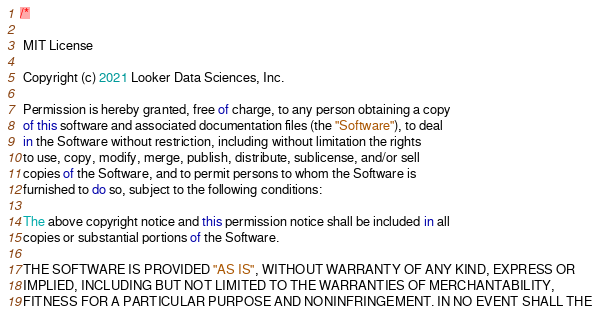<code> <loc_0><loc_0><loc_500><loc_500><_TypeScript_>/*

 MIT License

 Copyright (c) 2021 Looker Data Sciences, Inc.

 Permission is hereby granted, free of charge, to any person obtaining a copy
 of this software and associated documentation files (the "Software"), to deal
 in the Software without restriction, including without limitation the rights
 to use, copy, modify, merge, publish, distribute, sublicense, and/or sell
 copies of the Software, and to permit persons to whom the Software is
 furnished to do so, subject to the following conditions:

 The above copyright notice and this permission notice shall be included in all
 copies or substantial portions of the Software.

 THE SOFTWARE IS PROVIDED "AS IS", WITHOUT WARRANTY OF ANY KIND, EXPRESS OR
 IMPLIED, INCLUDING BUT NOT LIMITED TO THE WARRANTIES OF MERCHANTABILITY,
 FITNESS FOR A PARTICULAR PURPOSE AND NONINFRINGEMENT. IN NO EVENT SHALL THE</code> 